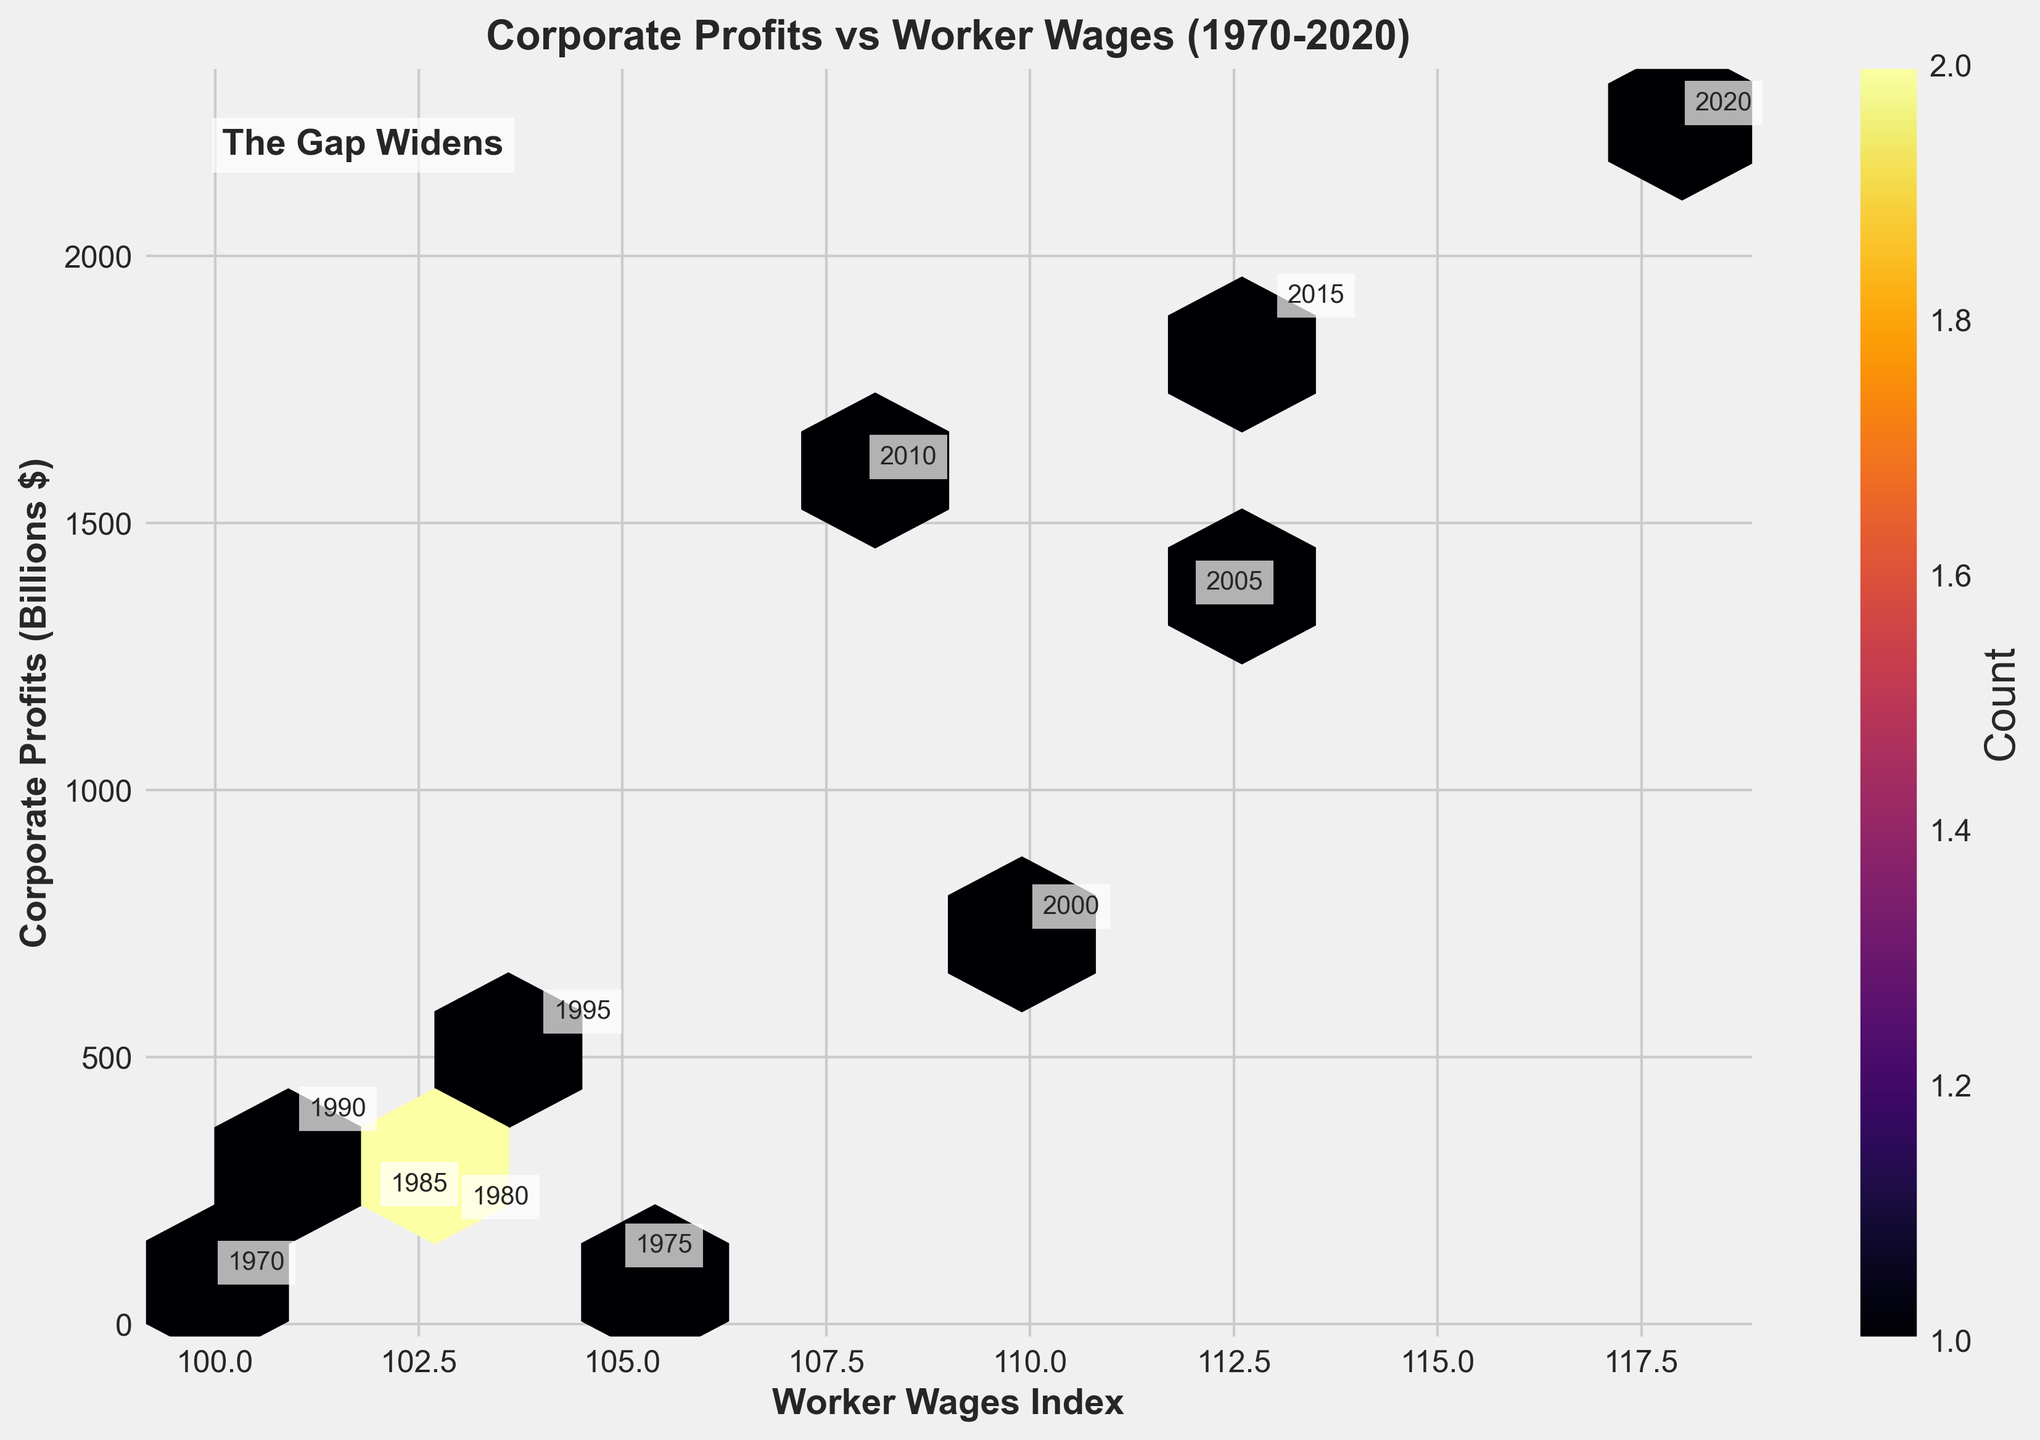What is the title of the plot? The title of the plot is located above the graph and gives an overview of what the plot represents. It reads "Corporate Profits vs Worker Wages (1970-2020)."
Answer: Corporate Profits vs Worker Wages (1970-2020) What do the x and y axes represent? The x-axis and y-axis labels explain what each axis represents. The x-axis represents "Worker Wages Index," and the y-axis represents "Corporate Profits (Billions $)."
Answer: Worker Wages Index; Corporate Profits (Billions $) How many hexagonal bins are used in the plot? You can count the visible hexagonal bins on the plot to determine this. According to the code provided, the gridsize is set to 10.
Answer: 10 What is the general trend shown by the data points from 1970 to 2020? By observing the annotations and the position of the data points over the years, we can see a trend. Corporate profits generally increase over time, while the Worker Wages Index shows minimal variation.
Answer: Corporate profits increase; Worker Wages Index varies slightly Which year has the highest Corporate Profits? By looking at the annotated years on the data points along the y-axis, we can identify which year corresponds to the highest value on the vertical scale. The year 2020 shows the highest Corporate Profits.
Answer: 2020 How does the Worker Wages Index in 2020 compare to that in 1970? Compare the x-axis positions of the 1970 and 2020 data points. The Worker Wages Index in 1970 is 100, and in 2020 it is 118. The index has increased by 18 points over these 50 years.
Answer: Increased by 18 points Is there a period where Worker Wages Index dropped? By observing the trend along the x-axis, we can see if the Worker Wages Index ever decreases. From 2000 to 2010, the index falls from 110 to 108.
Answer: Yes, from 2000 to 2010 Which year shows the largest increase in corporate profits compared to the previous recorded year? By examining the significant jumps along the y-axis, the period with the most substantial jump in corporate profits is from 1995 ($548 billion) to 2000 ($745 billion). The difference is $197 billion.
Answer: From 1995 to 2000 How many data points are present in the plot? The year annotations are placed on each data point. Counting these annotations informs us that there are data points for each year from 1970 to 2020.
Answer: 11 How is the density of data points represented in the plot? The color intensity within the hexagonal bins represents the density of data points. The colorbar on the right indicates that darker shades signify a higher count of data points.
Answer: By color intensity in hexagonal bins Where is the annotation "The Gap Widens" placed? The annotation is placed within the plot area and positioned in the top-left corner with coordinates (0.05, 0.95) in axis-relative units. This helps in drawing attention to the increasing divergence seen over time.
Answer: Top-left corner of the plot 